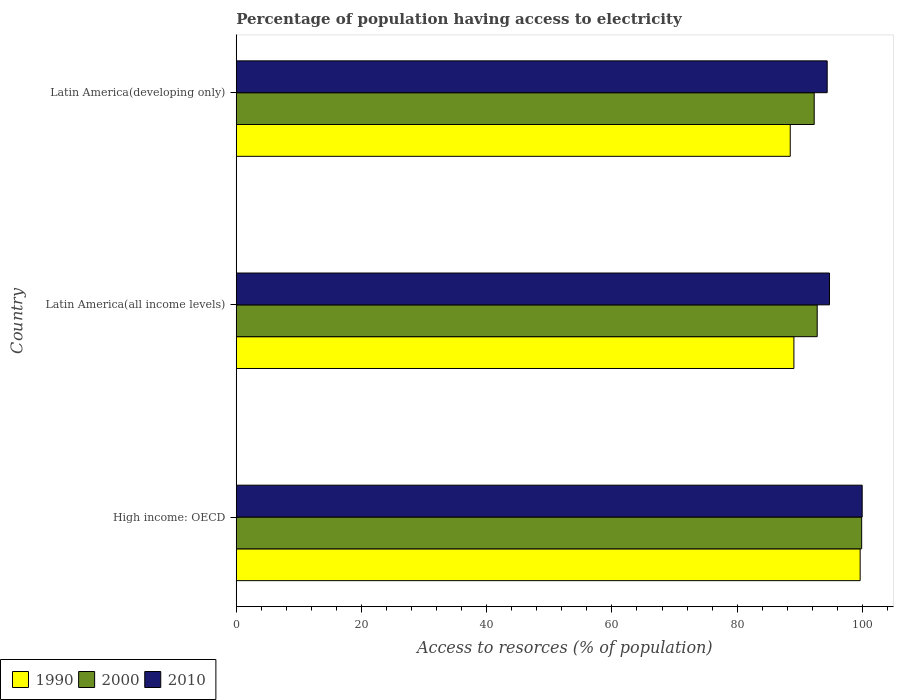How many groups of bars are there?
Ensure brevity in your answer.  3. Are the number of bars on each tick of the Y-axis equal?
Make the answer very short. Yes. How many bars are there on the 3rd tick from the bottom?
Your response must be concise. 3. What is the label of the 1st group of bars from the top?
Offer a terse response. Latin America(developing only). What is the percentage of population having access to electricity in 2010 in Latin America(all income levels)?
Ensure brevity in your answer.  94.75. Across all countries, what is the maximum percentage of population having access to electricity in 2010?
Give a very brief answer. 99.97. Across all countries, what is the minimum percentage of population having access to electricity in 2010?
Offer a very short reply. 94.38. In which country was the percentage of population having access to electricity in 2010 maximum?
Provide a succinct answer. High income: OECD. In which country was the percentage of population having access to electricity in 1990 minimum?
Your response must be concise. Latin America(developing only). What is the total percentage of population having access to electricity in 2000 in the graph?
Your response must be concise. 284.97. What is the difference between the percentage of population having access to electricity in 2000 in High income: OECD and that in Latin America(all income levels)?
Your answer should be very brief. 7.1. What is the difference between the percentage of population having access to electricity in 2010 in High income: OECD and the percentage of population having access to electricity in 2000 in Latin America(all income levels)?
Offer a very short reply. 7.19. What is the average percentage of population having access to electricity in 1990 per country?
Your answer should be compact. 92.39. What is the difference between the percentage of population having access to electricity in 2000 and percentage of population having access to electricity in 1990 in Latin America(developing only)?
Your response must be concise. 3.83. In how many countries, is the percentage of population having access to electricity in 2000 greater than 36 %?
Your response must be concise. 3. What is the ratio of the percentage of population having access to electricity in 1990 in Latin America(all income levels) to that in Latin America(developing only)?
Ensure brevity in your answer.  1.01. What is the difference between the highest and the second highest percentage of population having access to electricity in 1990?
Ensure brevity in your answer.  10.58. What is the difference between the highest and the lowest percentage of population having access to electricity in 2000?
Provide a succinct answer. 7.58. Is the sum of the percentage of population having access to electricity in 1990 in High income: OECD and Latin America(developing only) greater than the maximum percentage of population having access to electricity in 2010 across all countries?
Offer a very short reply. Yes. What does the 3rd bar from the top in High income: OECD represents?
Your answer should be very brief. 1990. Is it the case that in every country, the sum of the percentage of population having access to electricity in 1990 and percentage of population having access to electricity in 2000 is greater than the percentage of population having access to electricity in 2010?
Make the answer very short. Yes. Are all the bars in the graph horizontal?
Offer a terse response. Yes. How many countries are there in the graph?
Give a very brief answer. 3. What is the difference between two consecutive major ticks on the X-axis?
Offer a very short reply. 20. Does the graph contain grids?
Your answer should be very brief. No. Where does the legend appear in the graph?
Make the answer very short. Bottom left. How are the legend labels stacked?
Ensure brevity in your answer.  Horizontal. What is the title of the graph?
Your response must be concise. Percentage of population having access to electricity. What is the label or title of the X-axis?
Provide a short and direct response. Access to resorces (% of population). What is the label or title of the Y-axis?
Provide a succinct answer. Country. What is the Access to resorces (% of population) of 1990 in High income: OECD?
Your answer should be very brief. 99.64. What is the Access to resorces (% of population) in 2000 in High income: OECD?
Your answer should be very brief. 99.89. What is the Access to resorces (% of population) in 2010 in High income: OECD?
Make the answer very short. 99.97. What is the Access to resorces (% of population) in 1990 in Latin America(all income levels)?
Make the answer very short. 89.06. What is the Access to resorces (% of population) in 2000 in Latin America(all income levels)?
Offer a terse response. 92.78. What is the Access to resorces (% of population) in 2010 in Latin America(all income levels)?
Your answer should be compact. 94.75. What is the Access to resorces (% of population) of 1990 in Latin America(developing only)?
Provide a succinct answer. 88.48. What is the Access to resorces (% of population) in 2000 in Latin America(developing only)?
Give a very brief answer. 92.3. What is the Access to resorces (% of population) in 2010 in Latin America(developing only)?
Your answer should be very brief. 94.38. Across all countries, what is the maximum Access to resorces (% of population) of 1990?
Your answer should be very brief. 99.64. Across all countries, what is the maximum Access to resorces (% of population) of 2000?
Give a very brief answer. 99.89. Across all countries, what is the maximum Access to resorces (% of population) of 2010?
Your answer should be very brief. 99.97. Across all countries, what is the minimum Access to resorces (% of population) in 1990?
Give a very brief answer. 88.48. Across all countries, what is the minimum Access to resorces (% of population) of 2000?
Ensure brevity in your answer.  92.3. Across all countries, what is the minimum Access to resorces (% of population) in 2010?
Your answer should be compact. 94.38. What is the total Access to resorces (% of population) of 1990 in the graph?
Make the answer very short. 277.18. What is the total Access to resorces (% of population) of 2000 in the graph?
Offer a terse response. 284.97. What is the total Access to resorces (% of population) in 2010 in the graph?
Offer a terse response. 289.09. What is the difference between the Access to resorces (% of population) of 1990 in High income: OECD and that in Latin America(all income levels)?
Ensure brevity in your answer.  10.58. What is the difference between the Access to resorces (% of population) in 2000 in High income: OECD and that in Latin America(all income levels)?
Your answer should be very brief. 7.1. What is the difference between the Access to resorces (% of population) in 2010 in High income: OECD and that in Latin America(all income levels)?
Your answer should be compact. 5.22. What is the difference between the Access to resorces (% of population) in 1990 in High income: OECD and that in Latin America(developing only)?
Make the answer very short. 11.17. What is the difference between the Access to resorces (% of population) in 2000 in High income: OECD and that in Latin America(developing only)?
Your answer should be very brief. 7.58. What is the difference between the Access to resorces (% of population) in 2010 in High income: OECD and that in Latin America(developing only)?
Provide a short and direct response. 5.59. What is the difference between the Access to resorces (% of population) of 1990 in Latin America(all income levels) and that in Latin America(developing only)?
Your response must be concise. 0.59. What is the difference between the Access to resorces (% of population) in 2000 in Latin America(all income levels) and that in Latin America(developing only)?
Keep it short and to the point. 0.48. What is the difference between the Access to resorces (% of population) in 2010 in Latin America(all income levels) and that in Latin America(developing only)?
Make the answer very short. 0.37. What is the difference between the Access to resorces (% of population) of 1990 in High income: OECD and the Access to resorces (% of population) of 2000 in Latin America(all income levels)?
Your answer should be compact. 6.86. What is the difference between the Access to resorces (% of population) in 1990 in High income: OECD and the Access to resorces (% of population) in 2010 in Latin America(all income levels)?
Offer a terse response. 4.9. What is the difference between the Access to resorces (% of population) of 2000 in High income: OECD and the Access to resorces (% of population) of 2010 in Latin America(all income levels)?
Your answer should be very brief. 5.14. What is the difference between the Access to resorces (% of population) in 1990 in High income: OECD and the Access to resorces (% of population) in 2000 in Latin America(developing only)?
Give a very brief answer. 7.34. What is the difference between the Access to resorces (% of population) of 1990 in High income: OECD and the Access to resorces (% of population) of 2010 in Latin America(developing only)?
Your answer should be compact. 5.27. What is the difference between the Access to resorces (% of population) of 2000 in High income: OECD and the Access to resorces (% of population) of 2010 in Latin America(developing only)?
Your answer should be compact. 5.51. What is the difference between the Access to resorces (% of population) of 1990 in Latin America(all income levels) and the Access to resorces (% of population) of 2000 in Latin America(developing only)?
Your answer should be compact. -3.24. What is the difference between the Access to resorces (% of population) in 1990 in Latin America(all income levels) and the Access to resorces (% of population) in 2010 in Latin America(developing only)?
Provide a succinct answer. -5.32. What is the difference between the Access to resorces (% of population) of 2000 in Latin America(all income levels) and the Access to resorces (% of population) of 2010 in Latin America(developing only)?
Ensure brevity in your answer.  -1.6. What is the average Access to resorces (% of population) in 1990 per country?
Make the answer very short. 92.39. What is the average Access to resorces (% of population) of 2000 per country?
Your answer should be compact. 94.99. What is the average Access to resorces (% of population) of 2010 per country?
Your answer should be compact. 96.36. What is the difference between the Access to resorces (% of population) in 1990 and Access to resorces (% of population) in 2000 in High income: OECD?
Your answer should be very brief. -0.24. What is the difference between the Access to resorces (% of population) in 1990 and Access to resorces (% of population) in 2010 in High income: OECD?
Offer a very short reply. -0.33. What is the difference between the Access to resorces (% of population) in 2000 and Access to resorces (% of population) in 2010 in High income: OECD?
Your response must be concise. -0.08. What is the difference between the Access to resorces (% of population) of 1990 and Access to resorces (% of population) of 2000 in Latin America(all income levels)?
Keep it short and to the point. -3.72. What is the difference between the Access to resorces (% of population) in 1990 and Access to resorces (% of population) in 2010 in Latin America(all income levels)?
Offer a very short reply. -5.68. What is the difference between the Access to resorces (% of population) in 2000 and Access to resorces (% of population) in 2010 in Latin America(all income levels)?
Offer a very short reply. -1.96. What is the difference between the Access to resorces (% of population) in 1990 and Access to resorces (% of population) in 2000 in Latin America(developing only)?
Make the answer very short. -3.83. What is the difference between the Access to resorces (% of population) in 1990 and Access to resorces (% of population) in 2010 in Latin America(developing only)?
Ensure brevity in your answer.  -5.9. What is the difference between the Access to resorces (% of population) in 2000 and Access to resorces (% of population) in 2010 in Latin America(developing only)?
Your response must be concise. -2.07. What is the ratio of the Access to resorces (% of population) of 1990 in High income: OECD to that in Latin America(all income levels)?
Keep it short and to the point. 1.12. What is the ratio of the Access to resorces (% of population) in 2000 in High income: OECD to that in Latin America(all income levels)?
Provide a short and direct response. 1.08. What is the ratio of the Access to resorces (% of population) of 2010 in High income: OECD to that in Latin America(all income levels)?
Your answer should be compact. 1.06. What is the ratio of the Access to resorces (% of population) of 1990 in High income: OECD to that in Latin America(developing only)?
Give a very brief answer. 1.13. What is the ratio of the Access to resorces (% of population) in 2000 in High income: OECD to that in Latin America(developing only)?
Ensure brevity in your answer.  1.08. What is the ratio of the Access to resorces (% of population) in 2010 in High income: OECD to that in Latin America(developing only)?
Your response must be concise. 1.06. What is the ratio of the Access to resorces (% of population) of 1990 in Latin America(all income levels) to that in Latin America(developing only)?
Offer a terse response. 1.01. What is the ratio of the Access to resorces (% of population) of 2000 in Latin America(all income levels) to that in Latin America(developing only)?
Your response must be concise. 1.01. What is the ratio of the Access to resorces (% of population) of 2010 in Latin America(all income levels) to that in Latin America(developing only)?
Provide a short and direct response. 1. What is the difference between the highest and the second highest Access to resorces (% of population) in 1990?
Offer a terse response. 10.58. What is the difference between the highest and the second highest Access to resorces (% of population) of 2000?
Offer a very short reply. 7.1. What is the difference between the highest and the second highest Access to resorces (% of population) in 2010?
Your answer should be compact. 5.22. What is the difference between the highest and the lowest Access to resorces (% of population) in 1990?
Give a very brief answer. 11.17. What is the difference between the highest and the lowest Access to resorces (% of population) of 2000?
Offer a terse response. 7.58. What is the difference between the highest and the lowest Access to resorces (% of population) of 2010?
Ensure brevity in your answer.  5.59. 